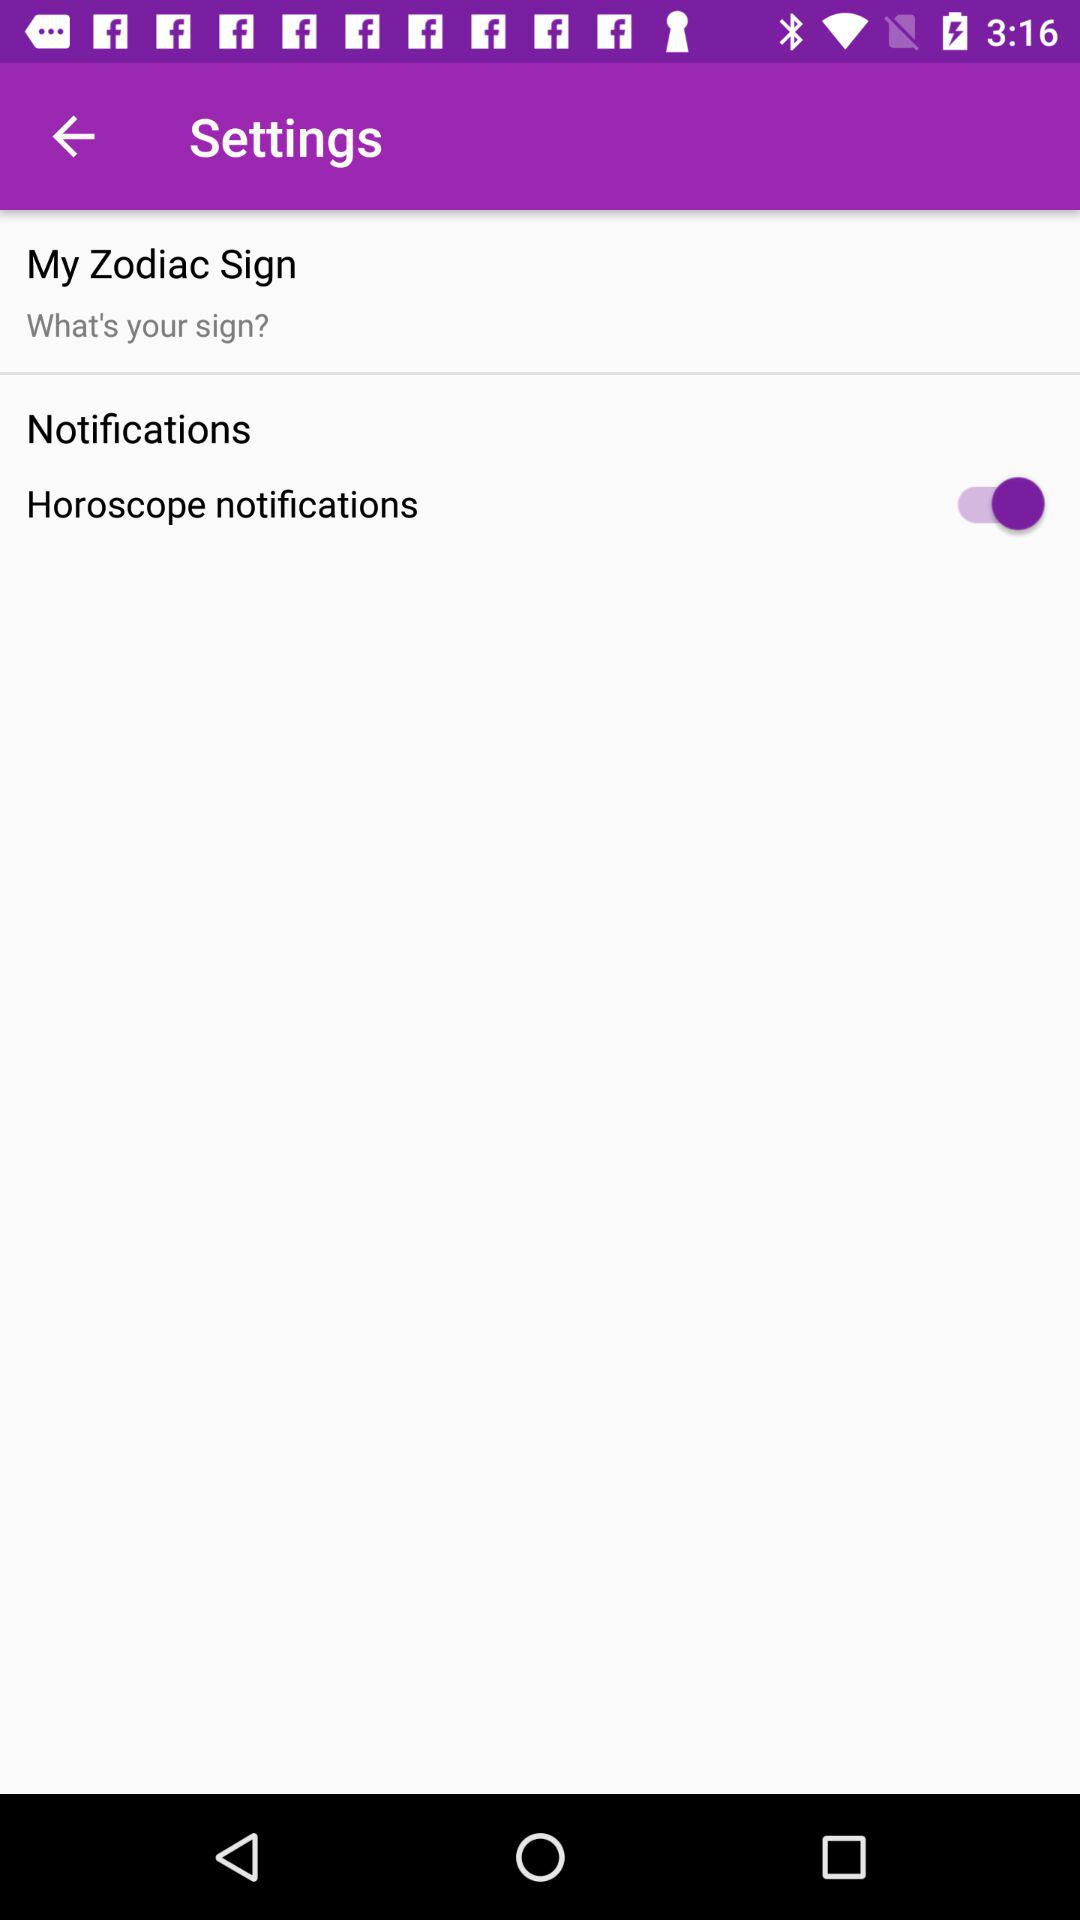What is the status of "Horoscope notifications"? The status is "on". 